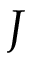<formula> <loc_0><loc_0><loc_500><loc_500>J</formula> 